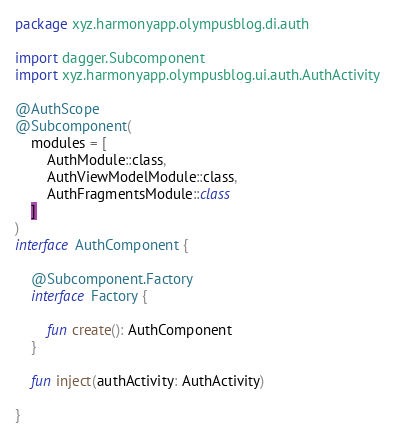<code> <loc_0><loc_0><loc_500><loc_500><_Kotlin_>package xyz.harmonyapp.olympusblog.di.auth

import dagger.Subcomponent
import xyz.harmonyapp.olympusblog.ui.auth.AuthActivity

@AuthScope
@Subcomponent(
    modules = [
        AuthModule::class,
        AuthViewModelModule::class,
        AuthFragmentsModule::class
    ]
)
interface AuthComponent {

    @Subcomponent.Factory
    interface Factory {

        fun create(): AuthComponent
    }

    fun inject(authActivity: AuthActivity)

}</code> 